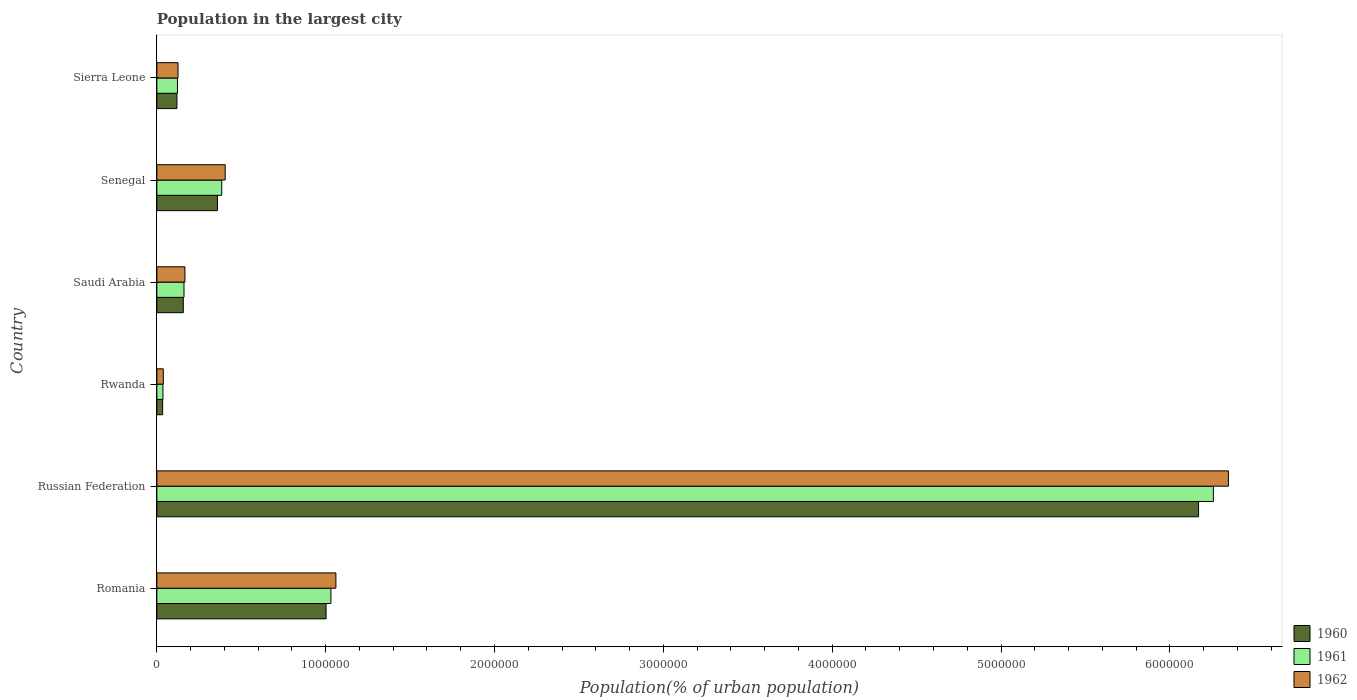How many different coloured bars are there?
Your response must be concise. 3. Are the number of bars per tick equal to the number of legend labels?
Your response must be concise. Yes. How many bars are there on the 4th tick from the top?
Your response must be concise. 3. What is the label of the 4th group of bars from the top?
Offer a very short reply. Rwanda. In how many cases, is the number of bars for a given country not equal to the number of legend labels?
Offer a terse response. 0. What is the population in the largest city in 1960 in Senegal?
Your response must be concise. 3.59e+05. Across all countries, what is the maximum population in the largest city in 1962?
Your response must be concise. 6.35e+06. Across all countries, what is the minimum population in the largest city in 1962?
Offer a terse response. 3.83e+04. In which country was the population in the largest city in 1962 maximum?
Give a very brief answer. Russian Federation. In which country was the population in the largest city in 1960 minimum?
Provide a short and direct response. Rwanda. What is the total population in the largest city in 1960 in the graph?
Give a very brief answer. 7.84e+06. What is the difference between the population in the largest city in 1962 in Senegal and that in Sierra Leone?
Ensure brevity in your answer.  2.79e+05. What is the difference between the population in the largest city in 1960 in Saudi Arabia and the population in the largest city in 1961 in Sierra Leone?
Provide a succinct answer. 3.45e+04. What is the average population in the largest city in 1962 per country?
Your answer should be very brief. 1.36e+06. What is the difference between the population in the largest city in 1960 and population in the largest city in 1961 in Senegal?
Provide a short and direct response. -2.53e+04. In how many countries, is the population in the largest city in 1962 greater than 4200000 %?
Offer a very short reply. 1. What is the ratio of the population in the largest city in 1961 in Saudi Arabia to that in Sierra Leone?
Your answer should be very brief. 1.32. Is the population in the largest city in 1962 in Rwanda less than that in Sierra Leone?
Offer a very short reply. Yes. What is the difference between the highest and the second highest population in the largest city in 1960?
Provide a succinct answer. 5.17e+06. What is the difference between the highest and the lowest population in the largest city in 1960?
Your response must be concise. 6.14e+06. In how many countries, is the population in the largest city in 1960 greater than the average population in the largest city in 1960 taken over all countries?
Your answer should be very brief. 1. How many bars are there?
Give a very brief answer. 18. Are all the bars in the graph horizontal?
Offer a very short reply. Yes. Does the graph contain any zero values?
Your answer should be compact. No. How are the legend labels stacked?
Ensure brevity in your answer.  Vertical. What is the title of the graph?
Your answer should be very brief. Population in the largest city. Does "2015" appear as one of the legend labels in the graph?
Your answer should be very brief. No. What is the label or title of the X-axis?
Ensure brevity in your answer.  Population(% of urban population). What is the label or title of the Y-axis?
Make the answer very short. Country. What is the Population(% of urban population) in 1960 in Romania?
Offer a very short reply. 1.00e+06. What is the Population(% of urban population) of 1961 in Romania?
Give a very brief answer. 1.03e+06. What is the Population(% of urban population) of 1962 in Romania?
Keep it short and to the point. 1.06e+06. What is the Population(% of urban population) of 1960 in Russian Federation?
Provide a succinct answer. 6.17e+06. What is the Population(% of urban population) in 1961 in Russian Federation?
Ensure brevity in your answer.  6.26e+06. What is the Population(% of urban population) in 1962 in Russian Federation?
Make the answer very short. 6.35e+06. What is the Population(% of urban population) in 1960 in Rwanda?
Keep it short and to the point. 3.43e+04. What is the Population(% of urban population) in 1961 in Rwanda?
Your answer should be very brief. 3.63e+04. What is the Population(% of urban population) in 1962 in Rwanda?
Ensure brevity in your answer.  3.83e+04. What is the Population(% of urban population) of 1960 in Saudi Arabia?
Provide a short and direct response. 1.57e+05. What is the Population(% of urban population) of 1961 in Saudi Arabia?
Make the answer very short. 1.61e+05. What is the Population(% of urban population) of 1962 in Saudi Arabia?
Your answer should be compact. 1.66e+05. What is the Population(% of urban population) of 1960 in Senegal?
Your response must be concise. 3.59e+05. What is the Population(% of urban population) of 1961 in Senegal?
Your response must be concise. 3.84e+05. What is the Population(% of urban population) in 1962 in Senegal?
Ensure brevity in your answer.  4.05e+05. What is the Population(% of urban population) of 1960 in Sierra Leone?
Keep it short and to the point. 1.19e+05. What is the Population(% of urban population) in 1961 in Sierra Leone?
Make the answer very short. 1.22e+05. What is the Population(% of urban population) in 1962 in Sierra Leone?
Provide a short and direct response. 1.25e+05. Across all countries, what is the maximum Population(% of urban population) in 1960?
Give a very brief answer. 6.17e+06. Across all countries, what is the maximum Population(% of urban population) of 1961?
Your answer should be compact. 6.26e+06. Across all countries, what is the maximum Population(% of urban population) in 1962?
Your response must be concise. 6.35e+06. Across all countries, what is the minimum Population(% of urban population) in 1960?
Make the answer very short. 3.43e+04. Across all countries, what is the minimum Population(% of urban population) in 1961?
Provide a succinct answer. 3.63e+04. Across all countries, what is the minimum Population(% of urban population) of 1962?
Your response must be concise. 3.83e+04. What is the total Population(% of urban population) in 1960 in the graph?
Your response must be concise. 7.84e+06. What is the total Population(% of urban population) of 1961 in the graph?
Provide a short and direct response. 7.99e+06. What is the total Population(% of urban population) of 1962 in the graph?
Your response must be concise. 8.14e+06. What is the difference between the Population(% of urban population) of 1960 in Romania and that in Russian Federation?
Offer a very short reply. -5.17e+06. What is the difference between the Population(% of urban population) of 1961 in Romania and that in Russian Federation?
Make the answer very short. -5.23e+06. What is the difference between the Population(% of urban population) of 1962 in Romania and that in Russian Federation?
Offer a terse response. -5.29e+06. What is the difference between the Population(% of urban population) in 1960 in Romania and that in Rwanda?
Make the answer very short. 9.68e+05. What is the difference between the Population(% of urban population) of 1961 in Romania and that in Rwanda?
Offer a very short reply. 9.95e+05. What is the difference between the Population(% of urban population) in 1962 in Romania and that in Rwanda?
Offer a very short reply. 1.02e+06. What is the difference between the Population(% of urban population) of 1960 in Romania and that in Saudi Arabia?
Provide a short and direct response. 8.46e+05. What is the difference between the Population(% of urban population) in 1961 in Romania and that in Saudi Arabia?
Provide a succinct answer. 8.70e+05. What is the difference between the Population(% of urban population) in 1962 in Romania and that in Saudi Arabia?
Make the answer very short. 8.94e+05. What is the difference between the Population(% of urban population) of 1960 in Romania and that in Senegal?
Your answer should be compact. 6.43e+05. What is the difference between the Population(% of urban population) in 1961 in Romania and that in Senegal?
Offer a terse response. 6.47e+05. What is the difference between the Population(% of urban population) in 1962 in Romania and that in Senegal?
Ensure brevity in your answer.  6.56e+05. What is the difference between the Population(% of urban population) of 1960 in Romania and that in Sierra Leone?
Provide a succinct answer. 8.83e+05. What is the difference between the Population(% of urban population) in 1961 in Romania and that in Sierra Leone?
Your answer should be very brief. 9.09e+05. What is the difference between the Population(% of urban population) in 1962 in Romania and that in Sierra Leone?
Your answer should be very brief. 9.35e+05. What is the difference between the Population(% of urban population) of 1960 in Russian Federation and that in Rwanda?
Provide a short and direct response. 6.14e+06. What is the difference between the Population(% of urban population) of 1961 in Russian Federation and that in Rwanda?
Provide a succinct answer. 6.22e+06. What is the difference between the Population(% of urban population) of 1962 in Russian Federation and that in Rwanda?
Keep it short and to the point. 6.31e+06. What is the difference between the Population(% of urban population) of 1960 in Russian Federation and that in Saudi Arabia?
Make the answer very short. 6.01e+06. What is the difference between the Population(% of urban population) of 1961 in Russian Federation and that in Saudi Arabia?
Give a very brief answer. 6.10e+06. What is the difference between the Population(% of urban population) in 1962 in Russian Federation and that in Saudi Arabia?
Your answer should be compact. 6.18e+06. What is the difference between the Population(% of urban population) in 1960 in Russian Federation and that in Senegal?
Provide a succinct answer. 5.81e+06. What is the difference between the Population(% of urban population) in 1961 in Russian Federation and that in Senegal?
Your answer should be compact. 5.87e+06. What is the difference between the Population(% of urban population) of 1962 in Russian Federation and that in Senegal?
Provide a succinct answer. 5.94e+06. What is the difference between the Population(% of urban population) in 1960 in Russian Federation and that in Sierra Leone?
Offer a very short reply. 6.05e+06. What is the difference between the Population(% of urban population) of 1961 in Russian Federation and that in Sierra Leone?
Make the answer very short. 6.14e+06. What is the difference between the Population(% of urban population) in 1962 in Russian Federation and that in Sierra Leone?
Make the answer very short. 6.22e+06. What is the difference between the Population(% of urban population) in 1960 in Rwanda and that in Saudi Arabia?
Ensure brevity in your answer.  -1.22e+05. What is the difference between the Population(% of urban population) of 1961 in Rwanda and that in Saudi Arabia?
Give a very brief answer. -1.25e+05. What is the difference between the Population(% of urban population) of 1962 in Rwanda and that in Saudi Arabia?
Offer a very short reply. -1.28e+05. What is the difference between the Population(% of urban population) of 1960 in Rwanda and that in Senegal?
Your answer should be very brief. -3.25e+05. What is the difference between the Population(% of urban population) of 1961 in Rwanda and that in Senegal?
Provide a succinct answer. -3.48e+05. What is the difference between the Population(% of urban population) of 1962 in Rwanda and that in Senegal?
Provide a succinct answer. -3.66e+05. What is the difference between the Population(% of urban population) of 1960 in Rwanda and that in Sierra Leone?
Give a very brief answer. -8.47e+04. What is the difference between the Population(% of urban population) in 1961 in Rwanda and that in Sierra Leone?
Provide a short and direct response. -8.59e+04. What is the difference between the Population(% of urban population) of 1962 in Rwanda and that in Sierra Leone?
Provide a short and direct response. -8.71e+04. What is the difference between the Population(% of urban population) in 1960 in Saudi Arabia and that in Senegal?
Ensure brevity in your answer.  -2.02e+05. What is the difference between the Population(% of urban population) in 1961 in Saudi Arabia and that in Senegal?
Make the answer very short. -2.24e+05. What is the difference between the Population(% of urban population) in 1962 in Saudi Arabia and that in Senegal?
Your response must be concise. -2.38e+05. What is the difference between the Population(% of urban population) of 1960 in Saudi Arabia and that in Sierra Leone?
Offer a terse response. 3.77e+04. What is the difference between the Population(% of urban population) of 1961 in Saudi Arabia and that in Sierra Leone?
Your answer should be compact. 3.87e+04. What is the difference between the Population(% of urban population) in 1962 in Saudi Arabia and that in Sierra Leone?
Offer a very short reply. 4.09e+04. What is the difference between the Population(% of urban population) in 1960 in Senegal and that in Sierra Leone?
Make the answer very short. 2.40e+05. What is the difference between the Population(% of urban population) in 1961 in Senegal and that in Sierra Leone?
Keep it short and to the point. 2.62e+05. What is the difference between the Population(% of urban population) of 1962 in Senegal and that in Sierra Leone?
Your answer should be very brief. 2.79e+05. What is the difference between the Population(% of urban population) in 1960 in Romania and the Population(% of urban population) in 1961 in Russian Federation?
Your answer should be compact. -5.26e+06. What is the difference between the Population(% of urban population) in 1960 in Romania and the Population(% of urban population) in 1962 in Russian Federation?
Provide a succinct answer. -5.34e+06. What is the difference between the Population(% of urban population) in 1961 in Romania and the Population(% of urban population) in 1962 in Russian Federation?
Offer a very short reply. -5.32e+06. What is the difference between the Population(% of urban population) of 1960 in Romania and the Population(% of urban population) of 1961 in Rwanda?
Provide a succinct answer. 9.66e+05. What is the difference between the Population(% of urban population) in 1960 in Romania and the Population(% of urban population) in 1962 in Rwanda?
Provide a succinct answer. 9.64e+05. What is the difference between the Population(% of urban population) in 1961 in Romania and the Population(% of urban population) in 1962 in Rwanda?
Your answer should be compact. 9.93e+05. What is the difference between the Population(% of urban population) in 1960 in Romania and the Population(% of urban population) in 1961 in Saudi Arabia?
Your answer should be very brief. 8.41e+05. What is the difference between the Population(% of urban population) of 1960 in Romania and the Population(% of urban population) of 1962 in Saudi Arabia?
Ensure brevity in your answer.  8.36e+05. What is the difference between the Population(% of urban population) in 1961 in Romania and the Population(% of urban population) in 1962 in Saudi Arabia?
Offer a terse response. 8.65e+05. What is the difference between the Population(% of urban population) in 1960 in Romania and the Population(% of urban population) in 1961 in Senegal?
Your answer should be compact. 6.18e+05. What is the difference between the Population(% of urban population) in 1960 in Romania and the Population(% of urban population) in 1962 in Senegal?
Provide a succinct answer. 5.98e+05. What is the difference between the Population(% of urban population) of 1961 in Romania and the Population(% of urban population) of 1962 in Senegal?
Your response must be concise. 6.26e+05. What is the difference between the Population(% of urban population) in 1960 in Romania and the Population(% of urban population) in 1961 in Sierra Leone?
Provide a short and direct response. 8.80e+05. What is the difference between the Population(% of urban population) in 1960 in Romania and the Population(% of urban population) in 1962 in Sierra Leone?
Provide a succinct answer. 8.77e+05. What is the difference between the Population(% of urban population) of 1961 in Romania and the Population(% of urban population) of 1962 in Sierra Leone?
Offer a terse response. 9.06e+05. What is the difference between the Population(% of urban population) of 1960 in Russian Federation and the Population(% of urban population) of 1961 in Rwanda?
Your answer should be very brief. 6.13e+06. What is the difference between the Population(% of urban population) of 1960 in Russian Federation and the Population(% of urban population) of 1962 in Rwanda?
Provide a succinct answer. 6.13e+06. What is the difference between the Population(% of urban population) of 1961 in Russian Federation and the Population(% of urban population) of 1962 in Rwanda?
Give a very brief answer. 6.22e+06. What is the difference between the Population(% of urban population) in 1960 in Russian Federation and the Population(% of urban population) in 1961 in Saudi Arabia?
Make the answer very short. 6.01e+06. What is the difference between the Population(% of urban population) of 1960 in Russian Federation and the Population(% of urban population) of 1962 in Saudi Arabia?
Keep it short and to the point. 6.00e+06. What is the difference between the Population(% of urban population) in 1961 in Russian Federation and the Population(% of urban population) in 1962 in Saudi Arabia?
Keep it short and to the point. 6.09e+06. What is the difference between the Population(% of urban population) in 1960 in Russian Federation and the Population(% of urban population) in 1961 in Senegal?
Your answer should be compact. 5.79e+06. What is the difference between the Population(% of urban population) in 1960 in Russian Federation and the Population(% of urban population) in 1962 in Senegal?
Your answer should be very brief. 5.77e+06. What is the difference between the Population(% of urban population) of 1961 in Russian Federation and the Population(% of urban population) of 1962 in Senegal?
Your response must be concise. 5.85e+06. What is the difference between the Population(% of urban population) of 1960 in Russian Federation and the Population(% of urban population) of 1961 in Sierra Leone?
Your answer should be very brief. 6.05e+06. What is the difference between the Population(% of urban population) of 1960 in Russian Federation and the Population(% of urban population) of 1962 in Sierra Leone?
Offer a very short reply. 6.04e+06. What is the difference between the Population(% of urban population) in 1961 in Russian Federation and the Population(% of urban population) in 1962 in Sierra Leone?
Your answer should be compact. 6.13e+06. What is the difference between the Population(% of urban population) of 1960 in Rwanda and the Population(% of urban population) of 1961 in Saudi Arabia?
Make the answer very short. -1.27e+05. What is the difference between the Population(% of urban population) in 1960 in Rwanda and the Population(% of urban population) in 1962 in Saudi Arabia?
Your answer should be compact. -1.32e+05. What is the difference between the Population(% of urban population) in 1961 in Rwanda and the Population(% of urban population) in 1962 in Saudi Arabia?
Offer a very short reply. -1.30e+05. What is the difference between the Population(% of urban population) in 1960 in Rwanda and the Population(% of urban population) in 1961 in Senegal?
Give a very brief answer. -3.50e+05. What is the difference between the Population(% of urban population) in 1960 in Rwanda and the Population(% of urban population) in 1962 in Senegal?
Your response must be concise. -3.70e+05. What is the difference between the Population(% of urban population) of 1961 in Rwanda and the Population(% of urban population) of 1962 in Senegal?
Provide a short and direct response. -3.69e+05. What is the difference between the Population(% of urban population) of 1960 in Rwanda and the Population(% of urban population) of 1961 in Sierra Leone?
Your answer should be very brief. -8.79e+04. What is the difference between the Population(% of urban population) of 1960 in Rwanda and the Population(% of urban population) of 1962 in Sierra Leone?
Your answer should be very brief. -9.11e+04. What is the difference between the Population(% of urban population) in 1961 in Rwanda and the Population(% of urban population) in 1962 in Sierra Leone?
Make the answer very short. -8.92e+04. What is the difference between the Population(% of urban population) of 1960 in Saudi Arabia and the Population(% of urban population) of 1961 in Senegal?
Provide a short and direct response. -2.28e+05. What is the difference between the Population(% of urban population) of 1960 in Saudi Arabia and the Population(% of urban population) of 1962 in Senegal?
Keep it short and to the point. -2.48e+05. What is the difference between the Population(% of urban population) of 1961 in Saudi Arabia and the Population(% of urban population) of 1962 in Senegal?
Keep it short and to the point. -2.44e+05. What is the difference between the Population(% of urban population) in 1960 in Saudi Arabia and the Population(% of urban population) in 1961 in Sierra Leone?
Ensure brevity in your answer.  3.45e+04. What is the difference between the Population(% of urban population) of 1960 in Saudi Arabia and the Population(% of urban population) of 1962 in Sierra Leone?
Give a very brief answer. 3.13e+04. What is the difference between the Population(% of urban population) of 1961 in Saudi Arabia and the Population(% of urban population) of 1962 in Sierra Leone?
Ensure brevity in your answer.  3.54e+04. What is the difference between the Population(% of urban population) of 1960 in Senegal and the Population(% of urban population) of 1961 in Sierra Leone?
Give a very brief answer. 2.37e+05. What is the difference between the Population(% of urban population) in 1960 in Senegal and the Population(% of urban population) in 1962 in Sierra Leone?
Provide a succinct answer. 2.34e+05. What is the difference between the Population(% of urban population) in 1961 in Senegal and the Population(% of urban population) in 1962 in Sierra Leone?
Provide a short and direct response. 2.59e+05. What is the average Population(% of urban population) in 1960 per country?
Make the answer very short. 1.31e+06. What is the average Population(% of urban population) of 1961 per country?
Your answer should be compact. 1.33e+06. What is the average Population(% of urban population) in 1962 per country?
Your response must be concise. 1.36e+06. What is the difference between the Population(% of urban population) in 1960 and Population(% of urban population) in 1961 in Romania?
Ensure brevity in your answer.  -2.87e+04. What is the difference between the Population(% of urban population) in 1960 and Population(% of urban population) in 1962 in Romania?
Keep it short and to the point. -5.83e+04. What is the difference between the Population(% of urban population) of 1961 and Population(% of urban population) of 1962 in Romania?
Your response must be concise. -2.96e+04. What is the difference between the Population(% of urban population) of 1960 and Population(% of urban population) of 1961 in Russian Federation?
Keep it short and to the point. -8.77e+04. What is the difference between the Population(% of urban population) in 1960 and Population(% of urban population) in 1962 in Russian Federation?
Your answer should be compact. -1.77e+05. What is the difference between the Population(% of urban population) in 1961 and Population(% of urban population) in 1962 in Russian Federation?
Your response must be concise. -8.91e+04. What is the difference between the Population(% of urban population) of 1960 and Population(% of urban population) of 1961 in Rwanda?
Offer a very short reply. -1932. What is the difference between the Population(% of urban population) in 1960 and Population(% of urban population) in 1962 in Rwanda?
Your answer should be compact. -3976. What is the difference between the Population(% of urban population) in 1961 and Population(% of urban population) in 1962 in Rwanda?
Ensure brevity in your answer.  -2044. What is the difference between the Population(% of urban population) of 1960 and Population(% of urban population) of 1961 in Saudi Arabia?
Give a very brief answer. -4157. What is the difference between the Population(% of urban population) in 1960 and Population(% of urban population) in 1962 in Saudi Arabia?
Keep it short and to the point. -9658. What is the difference between the Population(% of urban population) of 1961 and Population(% of urban population) of 1962 in Saudi Arabia?
Keep it short and to the point. -5501. What is the difference between the Population(% of urban population) in 1960 and Population(% of urban population) in 1961 in Senegal?
Provide a succinct answer. -2.53e+04. What is the difference between the Population(% of urban population) of 1960 and Population(% of urban population) of 1962 in Senegal?
Offer a very short reply. -4.57e+04. What is the difference between the Population(% of urban population) in 1961 and Population(% of urban population) in 1962 in Senegal?
Provide a short and direct response. -2.04e+04. What is the difference between the Population(% of urban population) in 1960 and Population(% of urban population) in 1961 in Sierra Leone?
Keep it short and to the point. -3159. What is the difference between the Population(% of urban population) of 1960 and Population(% of urban population) of 1962 in Sierra Leone?
Provide a succinct answer. -6406. What is the difference between the Population(% of urban population) in 1961 and Population(% of urban population) in 1962 in Sierra Leone?
Offer a very short reply. -3247. What is the ratio of the Population(% of urban population) in 1960 in Romania to that in Russian Federation?
Ensure brevity in your answer.  0.16. What is the ratio of the Population(% of urban population) of 1961 in Romania to that in Russian Federation?
Offer a very short reply. 0.16. What is the ratio of the Population(% of urban population) of 1962 in Romania to that in Russian Federation?
Make the answer very short. 0.17. What is the ratio of the Population(% of urban population) in 1960 in Romania to that in Rwanda?
Your answer should be very brief. 29.21. What is the ratio of the Population(% of urban population) in 1961 in Romania to that in Rwanda?
Offer a very short reply. 28.44. What is the ratio of the Population(% of urban population) of 1962 in Romania to that in Rwanda?
Provide a short and direct response. 27.69. What is the ratio of the Population(% of urban population) in 1960 in Romania to that in Saudi Arabia?
Your answer should be compact. 6.4. What is the ratio of the Population(% of urban population) of 1961 in Romania to that in Saudi Arabia?
Offer a terse response. 6.41. What is the ratio of the Population(% of urban population) in 1962 in Romania to that in Saudi Arabia?
Your answer should be compact. 6.38. What is the ratio of the Population(% of urban population) of 1960 in Romania to that in Senegal?
Make the answer very short. 2.79. What is the ratio of the Population(% of urban population) in 1961 in Romania to that in Senegal?
Provide a short and direct response. 2.68. What is the ratio of the Population(% of urban population) of 1962 in Romania to that in Senegal?
Offer a terse response. 2.62. What is the ratio of the Population(% of urban population) of 1960 in Romania to that in Sierra Leone?
Your answer should be compact. 8.42. What is the ratio of the Population(% of urban population) of 1961 in Romania to that in Sierra Leone?
Your response must be concise. 8.44. What is the ratio of the Population(% of urban population) of 1962 in Romania to that in Sierra Leone?
Offer a very short reply. 8.46. What is the ratio of the Population(% of urban population) of 1960 in Russian Federation to that in Rwanda?
Provide a succinct answer. 179.78. What is the ratio of the Population(% of urban population) of 1961 in Russian Federation to that in Rwanda?
Make the answer very short. 172.62. What is the ratio of the Population(% of urban population) in 1962 in Russian Federation to that in Rwanda?
Provide a short and direct response. 165.73. What is the ratio of the Population(% of urban population) in 1960 in Russian Federation to that in Saudi Arabia?
Provide a short and direct response. 39.37. What is the ratio of the Population(% of urban population) in 1961 in Russian Federation to that in Saudi Arabia?
Offer a terse response. 38.9. What is the ratio of the Population(% of urban population) of 1962 in Russian Federation to that in Saudi Arabia?
Your response must be concise. 38.15. What is the ratio of the Population(% of urban population) in 1960 in Russian Federation to that in Senegal?
Your answer should be very brief. 17.18. What is the ratio of the Population(% of urban population) of 1961 in Russian Federation to that in Senegal?
Your response must be concise. 16.28. What is the ratio of the Population(% of urban population) in 1962 in Russian Federation to that in Senegal?
Offer a terse response. 15.68. What is the ratio of the Population(% of urban population) in 1960 in Russian Federation to that in Sierra Leone?
Keep it short and to the point. 51.84. What is the ratio of the Population(% of urban population) in 1961 in Russian Federation to that in Sierra Leone?
Offer a terse response. 51.22. What is the ratio of the Population(% of urban population) in 1962 in Russian Federation to that in Sierra Leone?
Your answer should be compact. 50.6. What is the ratio of the Population(% of urban population) in 1960 in Rwanda to that in Saudi Arabia?
Offer a terse response. 0.22. What is the ratio of the Population(% of urban population) in 1961 in Rwanda to that in Saudi Arabia?
Make the answer very short. 0.23. What is the ratio of the Population(% of urban population) of 1962 in Rwanda to that in Saudi Arabia?
Ensure brevity in your answer.  0.23. What is the ratio of the Population(% of urban population) in 1960 in Rwanda to that in Senegal?
Provide a short and direct response. 0.1. What is the ratio of the Population(% of urban population) of 1961 in Rwanda to that in Senegal?
Make the answer very short. 0.09. What is the ratio of the Population(% of urban population) in 1962 in Rwanda to that in Senegal?
Offer a very short reply. 0.09. What is the ratio of the Population(% of urban population) of 1960 in Rwanda to that in Sierra Leone?
Your answer should be very brief. 0.29. What is the ratio of the Population(% of urban population) in 1961 in Rwanda to that in Sierra Leone?
Offer a very short reply. 0.3. What is the ratio of the Population(% of urban population) of 1962 in Rwanda to that in Sierra Leone?
Provide a succinct answer. 0.31. What is the ratio of the Population(% of urban population) of 1960 in Saudi Arabia to that in Senegal?
Your answer should be very brief. 0.44. What is the ratio of the Population(% of urban population) of 1961 in Saudi Arabia to that in Senegal?
Your response must be concise. 0.42. What is the ratio of the Population(% of urban population) in 1962 in Saudi Arabia to that in Senegal?
Ensure brevity in your answer.  0.41. What is the ratio of the Population(% of urban population) of 1960 in Saudi Arabia to that in Sierra Leone?
Provide a short and direct response. 1.32. What is the ratio of the Population(% of urban population) in 1961 in Saudi Arabia to that in Sierra Leone?
Provide a succinct answer. 1.32. What is the ratio of the Population(% of urban population) in 1962 in Saudi Arabia to that in Sierra Leone?
Give a very brief answer. 1.33. What is the ratio of the Population(% of urban population) in 1960 in Senegal to that in Sierra Leone?
Provide a succinct answer. 3.02. What is the ratio of the Population(% of urban population) of 1961 in Senegal to that in Sierra Leone?
Keep it short and to the point. 3.15. What is the ratio of the Population(% of urban population) of 1962 in Senegal to that in Sierra Leone?
Provide a short and direct response. 3.23. What is the difference between the highest and the second highest Population(% of urban population) of 1960?
Provide a succinct answer. 5.17e+06. What is the difference between the highest and the second highest Population(% of urban population) in 1961?
Your response must be concise. 5.23e+06. What is the difference between the highest and the second highest Population(% of urban population) of 1962?
Give a very brief answer. 5.29e+06. What is the difference between the highest and the lowest Population(% of urban population) of 1960?
Provide a succinct answer. 6.14e+06. What is the difference between the highest and the lowest Population(% of urban population) in 1961?
Offer a terse response. 6.22e+06. What is the difference between the highest and the lowest Population(% of urban population) of 1962?
Keep it short and to the point. 6.31e+06. 